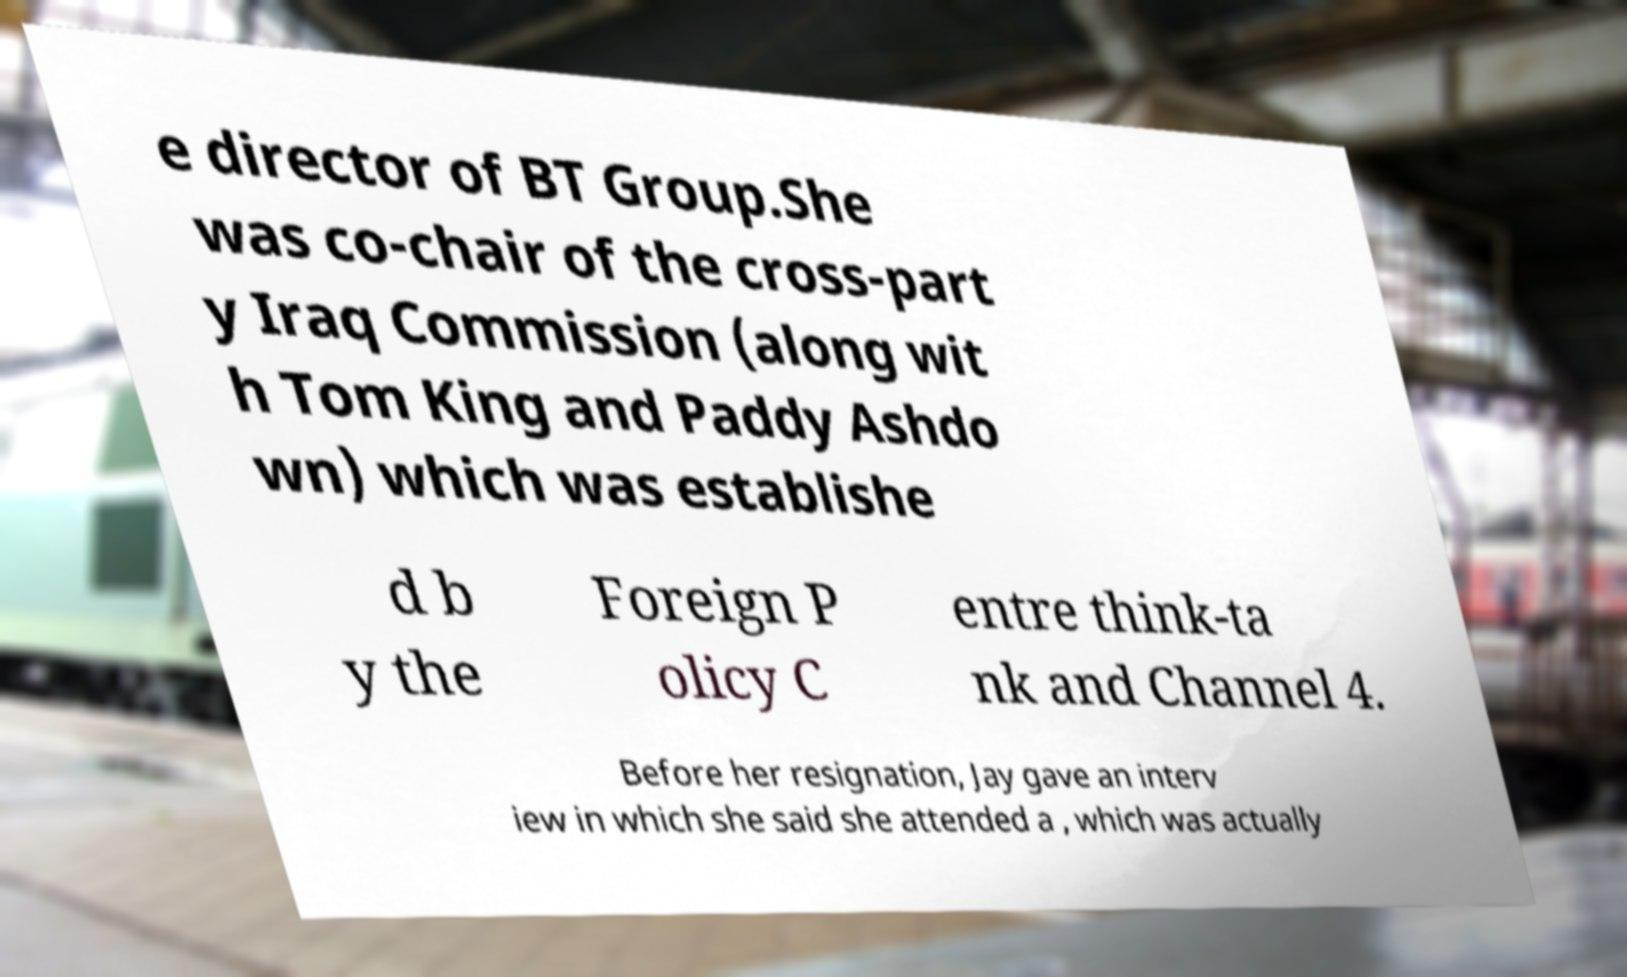Please identify and transcribe the text found in this image. e director of BT Group.She was co-chair of the cross-part y Iraq Commission (along wit h Tom King and Paddy Ashdo wn) which was establishe d b y the Foreign P olicy C entre think-ta nk and Channel 4. Before her resignation, Jay gave an interv iew in which she said she attended a , which was actually 